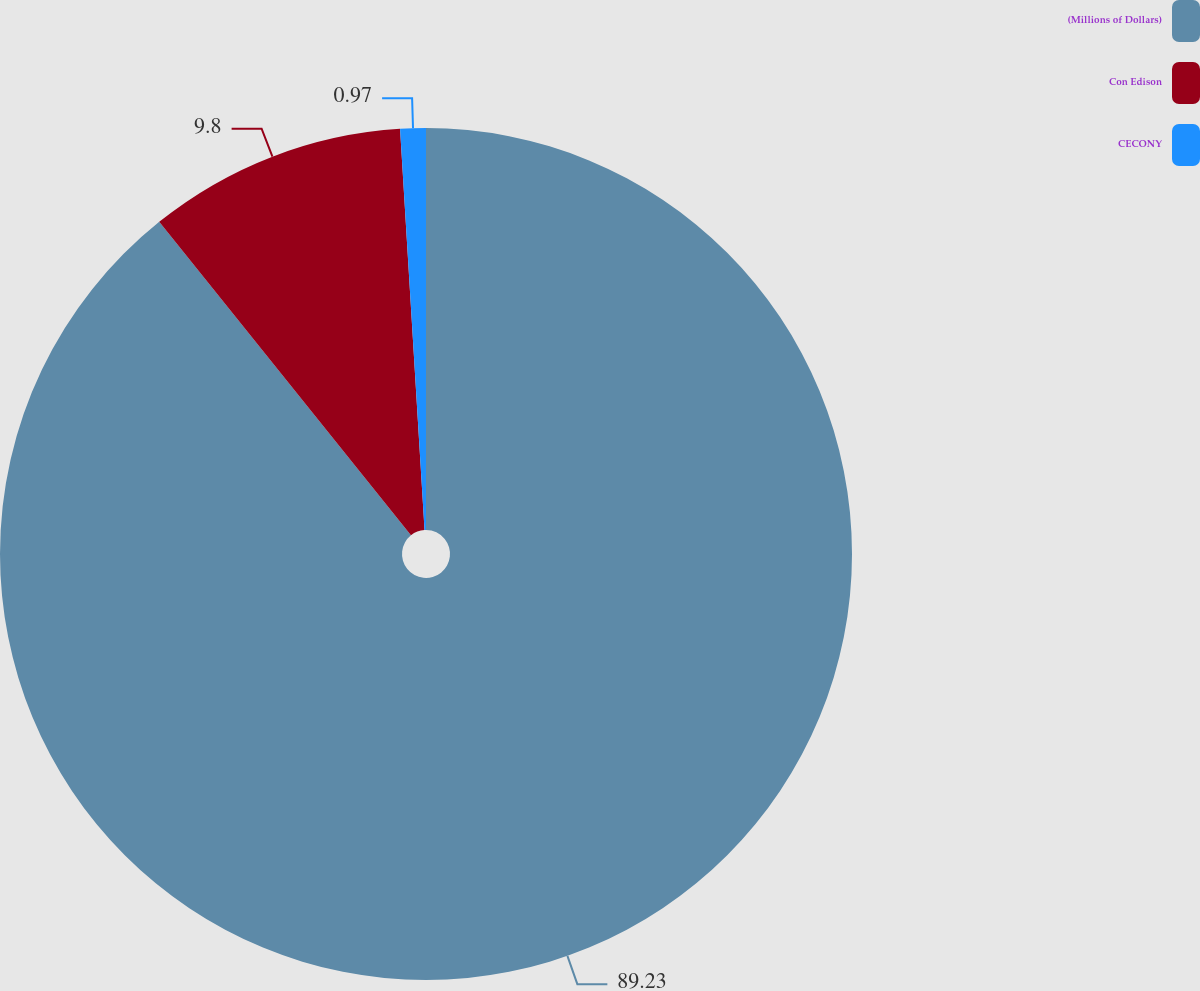<chart> <loc_0><loc_0><loc_500><loc_500><pie_chart><fcel>(Millions of Dollars)<fcel>Con Edison<fcel>CECONY<nl><fcel>89.23%<fcel>9.8%<fcel>0.97%<nl></chart> 